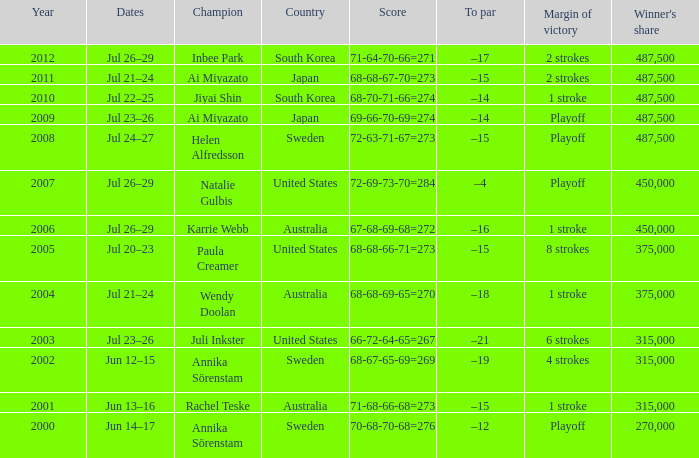Which Country has a Score of 70-68-70-68=276? Sweden. 